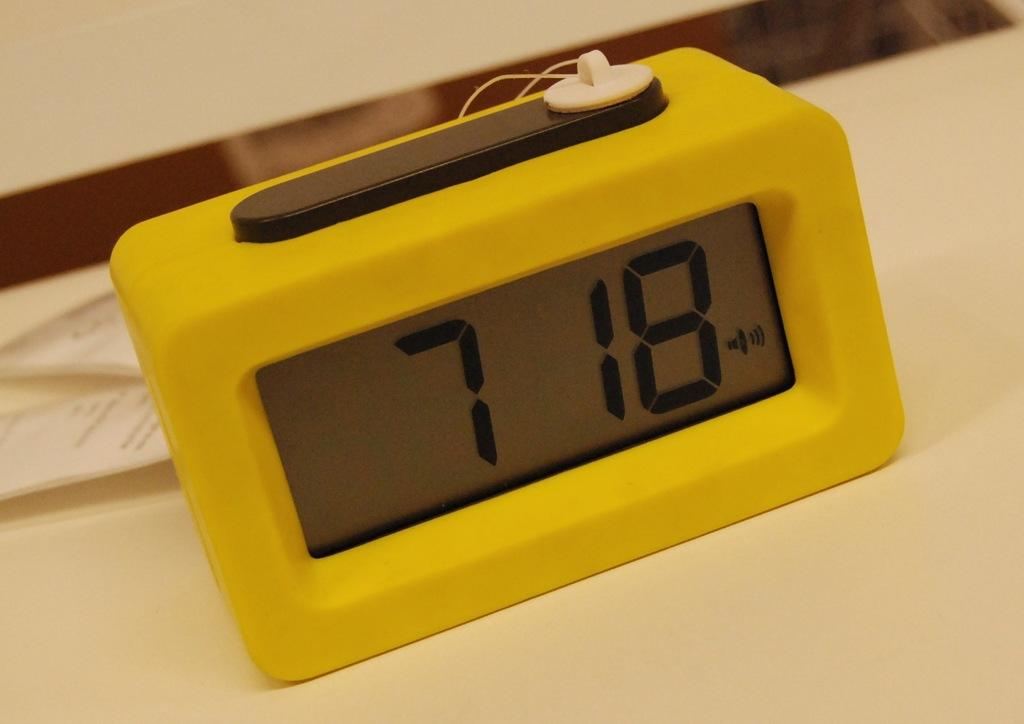<image>
Summarize the visual content of the image. Yellow clock sits on a table and reads 7 18 